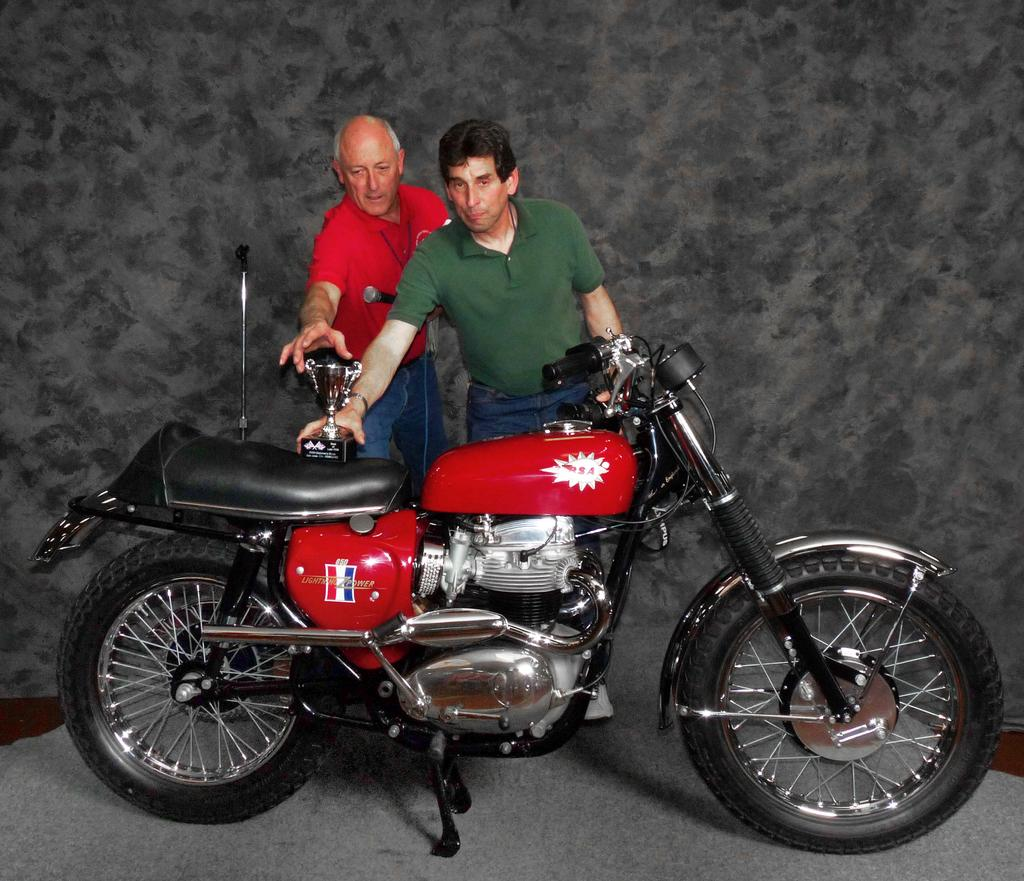How many people are in the image? There are two men in the image. What are the men doing in the image? The men are standing in the middle of the image. What object is in front of the men? The men are standing in front of a bike. What is on the bike? There is a shield on the bike. What is the color of the background in the image? The background of the image appears to be black. How many porter snails are crawling on the bike in the image? There are no porter snails present in the image, and therefore no such activity can be observed. 